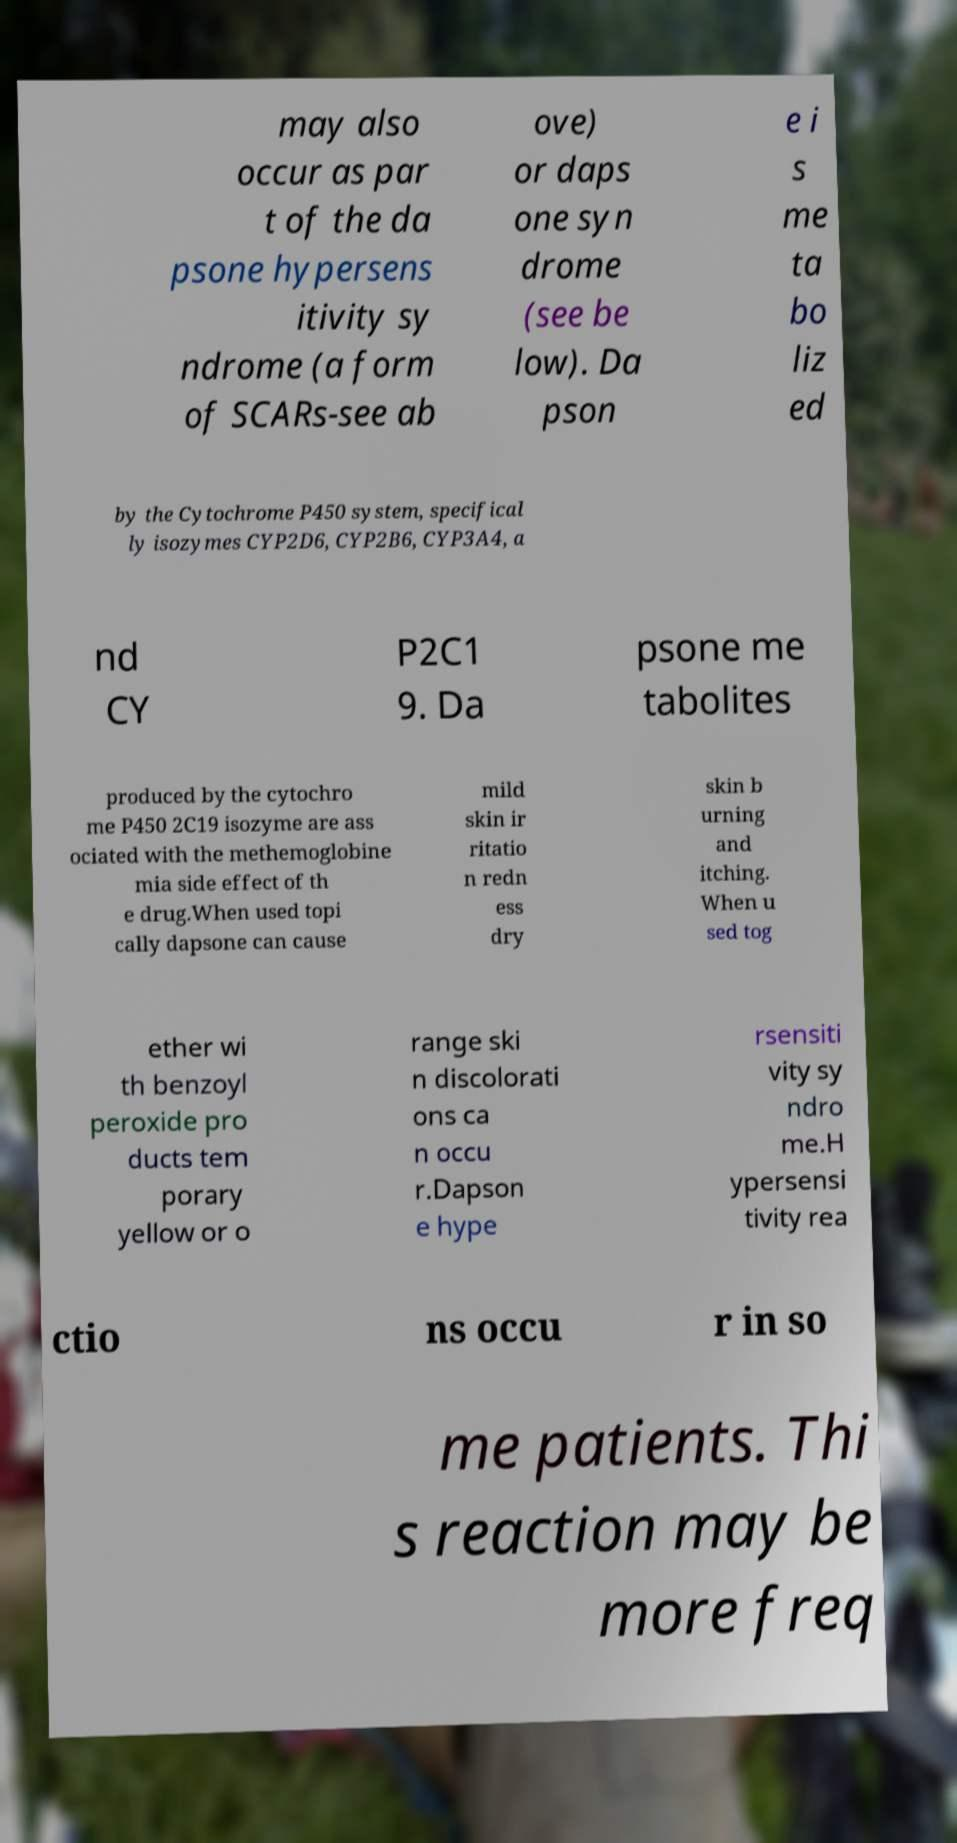Can you accurately transcribe the text from the provided image for me? may also occur as par t of the da psone hypersens itivity sy ndrome (a form of SCARs-see ab ove) or daps one syn drome (see be low). Da pson e i s me ta bo liz ed by the Cytochrome P450 system, specifical ly isozymes CYP2D6, CYP2B6, CYP3A4, a nd CY P2C1 9. Da psone me tabolites produced by the cytochro me P450 2C19 isozyme are ass ociated with the methemoglobine mia side effect of th e drug.When used topi cally dapsone can cause mild skin ir ritatio n redn ess dry skin b urning and itching. When u sed tog ether wi th benzoyl peroxide pro ducts tem porary yellow or o range ski n discolorati ons ca n occu r.Dapson e hype rsensiti vity sy ndro me.H ypersensi tivity rea ctio ns occu r in so me patients. Thi s reaction may be more freq 